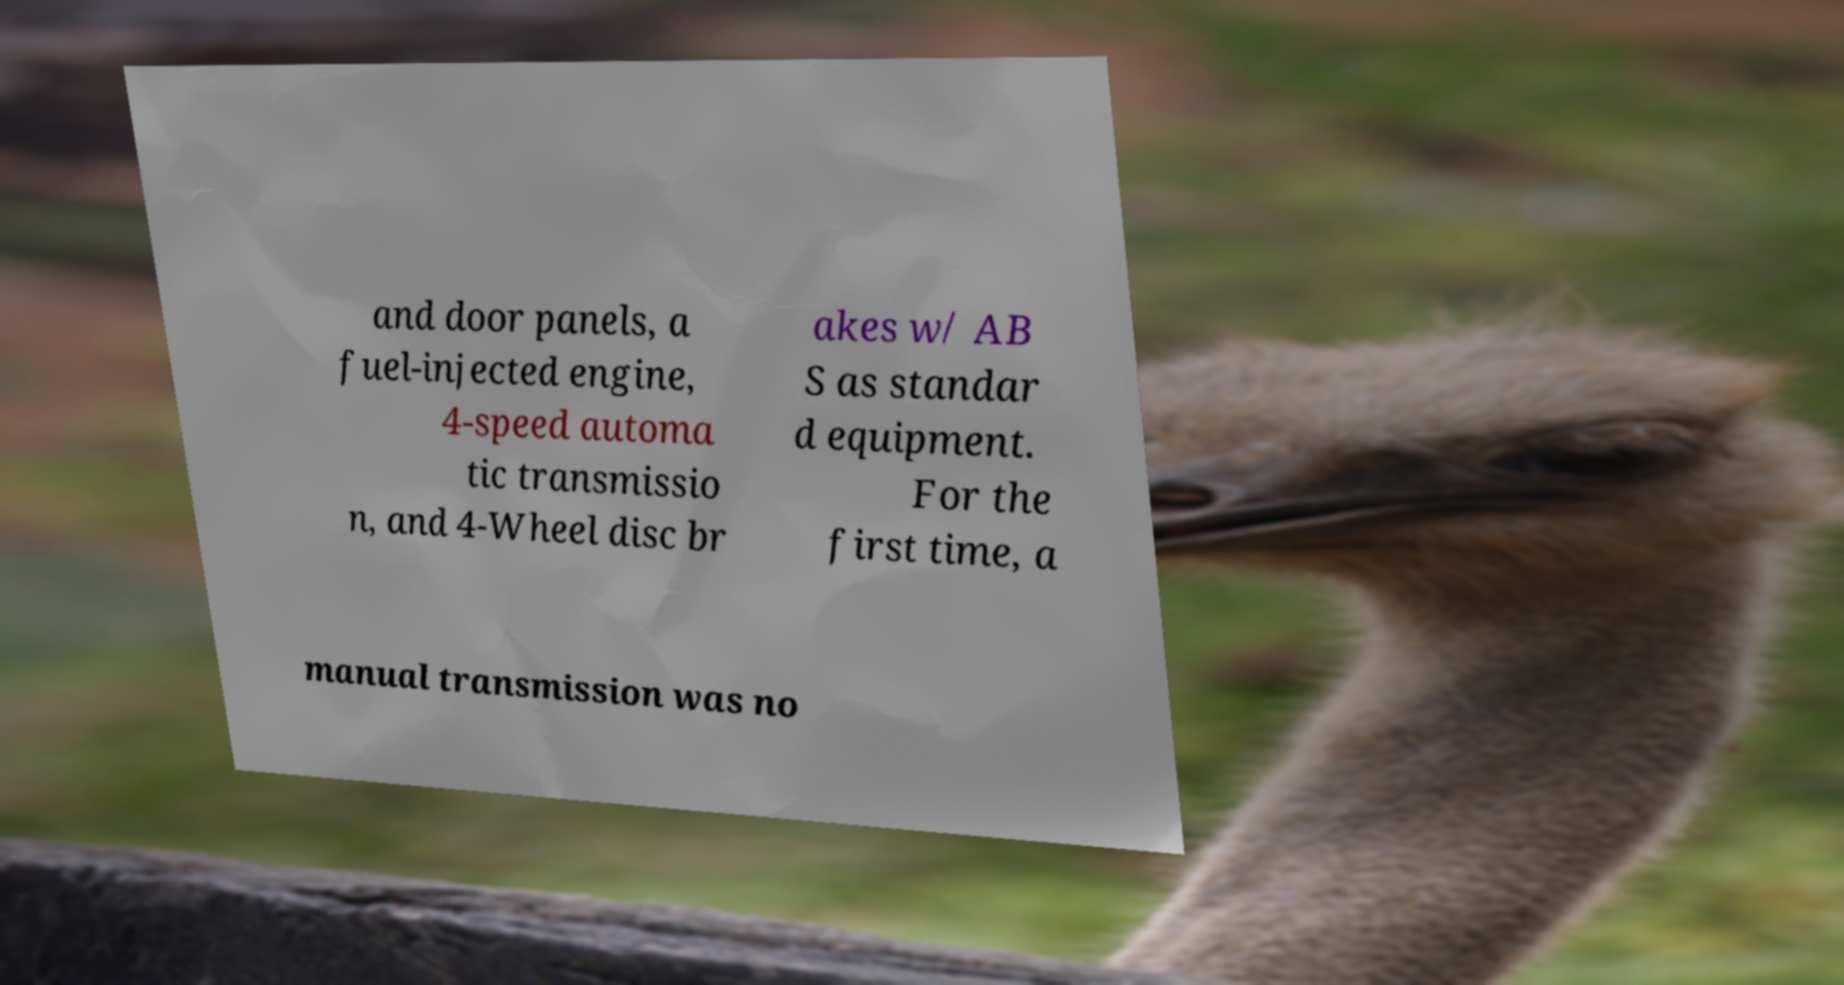Could you assist in decoding the text presented in this image and type it out clearly? and door panels, a fuel-injected engine, 4-speed automa tic transmissio n, and 4-Wheel disc br akes w/ AB S as standar d equipment. For the first time, a manual transmission was no 